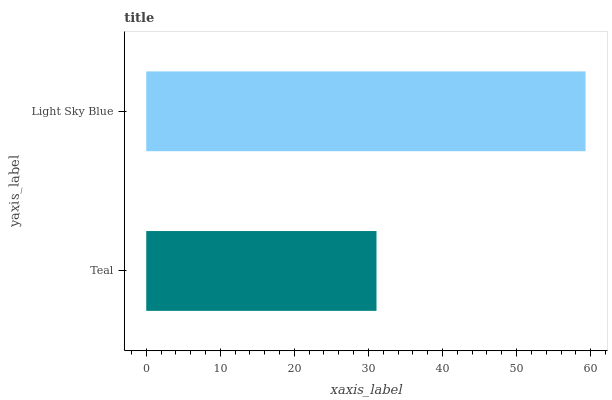Is Teal the minimum?
Answer yes or no. Yes. Is Light Sky Blue the maximum?
Answer yes or no. Yes. Is Light Sky Blue the minimum?
Answer yes or no. No. Is Light Sky Blue greater than Teal?
Answer yes or no. Yes. Is Teal less than Light Sky Blue?
Answer yes or no. Yes. Is Teal greater than Light Sky Blue?
Answer yes or no. No. Is Light Sky Blue less than Teal?
Answer yes or no. No. Is Light Sky Blue the high median?
Answer yes or no. Yes. Is Teal the low median?
Answer yes or no. Yes. Is Teal the high median?
Answer yes or no. No. Is Light Sky Blue the low median?
Answer yes or no. No. 